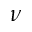Convert formula to latex. <formula><loc_0><loc_0><loc_500><loc_500>\nu</formula> 